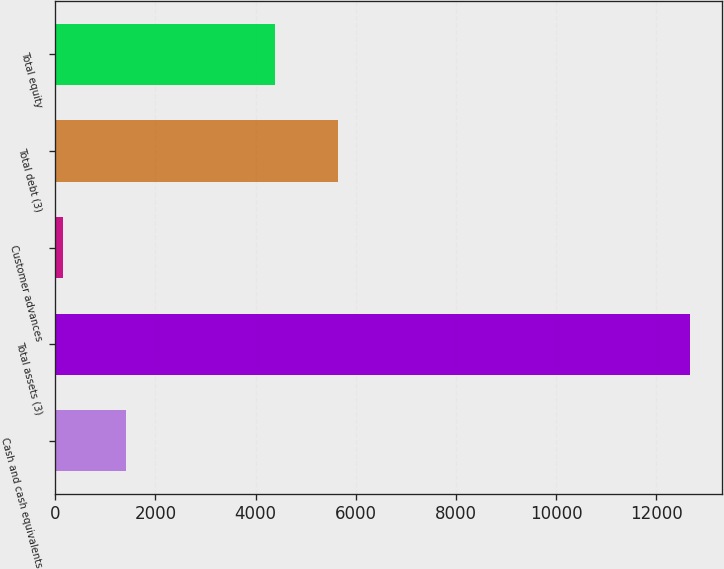Convert chart to OTSL. <chart><loc_0><loc_0><loc_500><loc_500><bar_chart><fcel>Cash and cash equivalents<fcel>Total assets (3)<fcel>Customer advances<fcel>Total debt (3)<fcel>Total equity<nl><fcel>1414.1<fcel>12683<fcel>162<fcel>5639.1<fcel>4387<nl></chart> 